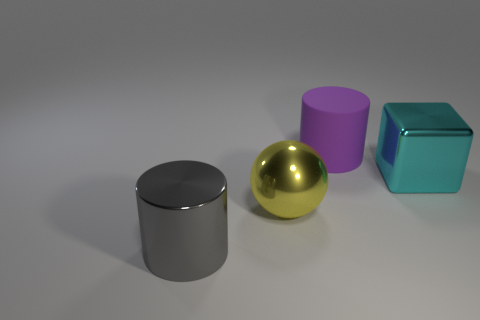Add 1 small gray matte blocks. How many objects exist? 5 Add 3 large matte things. How many large matte things are left? 4 Add 3 big purple matte things. How many big purple matte things exist? 4 Subtract 0 cyan cylinders. How many objects are left? 4 Subtract all balls. How many objects are left? 3 Subtract all gray metallic objects. Subtract all yellow shiny balls. How many objects are left? 2 